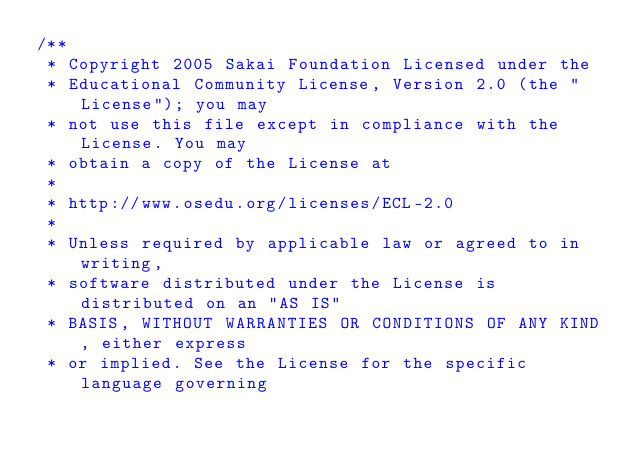<code> <loc_0><loc_0><loc_500><loc_500><_Java_>/**
 * Copyright 2005 Sakai Foundation Licensed under the
 * Educational Community License, Version 2.0 (the "License"); you may
 * not use this file except in compliance with the License. You may
 * obtain a copy of the License at
 *
 * http://www.osedu.org/licenses/ECL-2.0
 *
 * Unless required by applicable law or agreed to in writing,
 * software distributed under the License is distributed on an "AS IS"
 * BASIS, WITHOUT WARRANTIES OR CONDITIONS OF ANY KIND, either express
 * or implied. See the License for the specific language governing</code> 